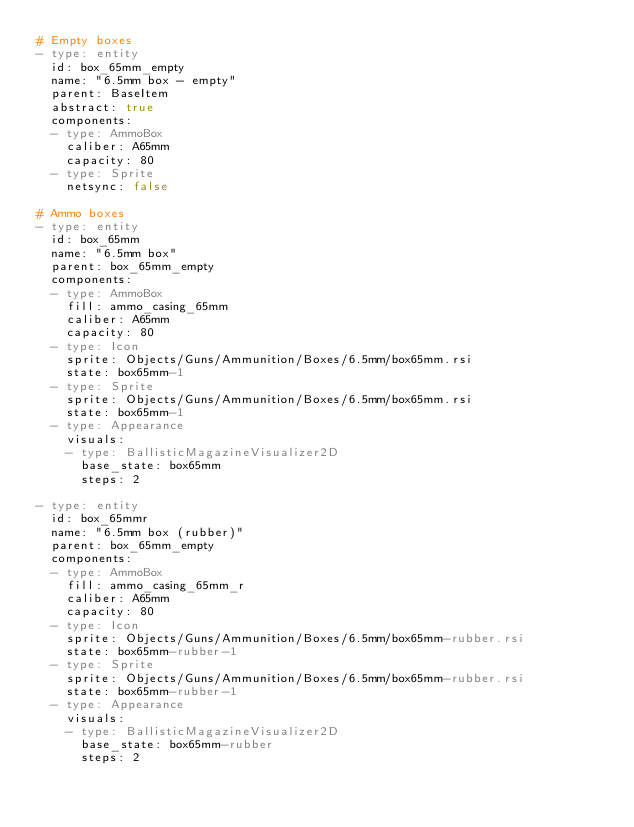Convert code to text. <code><loc_0><loc_0><loc_500><loc_500><_YAML_># Empty boxes
- type: entity
  id: box_65mm_empty
  name: "6.5mm box - empty"
  parent: BaseItem
  abstract: true
  components:
  - type: AmmoBox
    caliber: A65mm
    capacity: 80
  - type: Sprite
    netsync: false

# Ammo boxes
- type: entity
  id: box_65mm
  name: "6.5mm box"
  parent: box_65mm_empty
  components:
  - type: AmmoBox
    fill: ammo_casing_65mm
    caliber: A65mm
    capacity: 80
  - type: Icon
    sprite: Objects/Guns/Ammunition/Boxes/6.5mm/box65mm.rsi
    state: box65mm-1
  - type: Sprite
    sprite: Objects/Guns/Ammunition/Boxes/6.5mm/box65mm.rsi
    state: box65mm-1
  - type: Appearance
    visuals:
    - type: BallisticMagazineVisualizer2D
      base_state: box65mm
      steps: 2

- type: entity
  id: box_65mmr
  name: "6.5mm box (rubber)"
  parent: box_65mm_empty
  components:
  - type: AmmoBox
    fill: ammo_casing_65mm_r
    caliber: A65mm
    capacity: 80
  - type: Icon
    sprite: Objects/Guns/Ammunition/Boxes/6.5mm/box65mm-rubber.rsi
    state: box65mm-rubber-1
  - type: Sprite
    sprite: Objects/Guns/Ammunition/Boxes/6.5mm/box65mm-rubber.rsi
    state: box65mm-rubber-1
  - type: Appearance
    visuals:
    - type: BallisticMagazineVisualizer2D
      base_state: box65mm-rubber
      steps: 2
</code> 